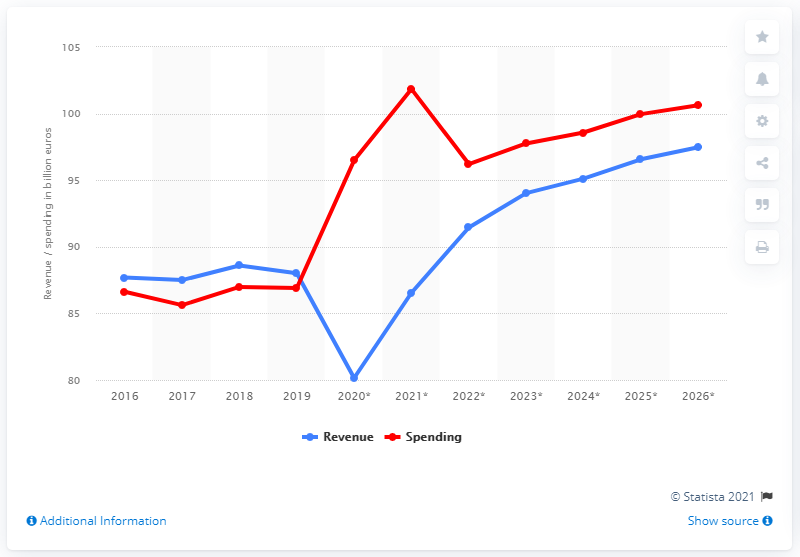Identify some key points in this picture. According to data from 2019, Greece's government spending was approximately 86.55. In 2019, Greece's government revenue was 88.01. 